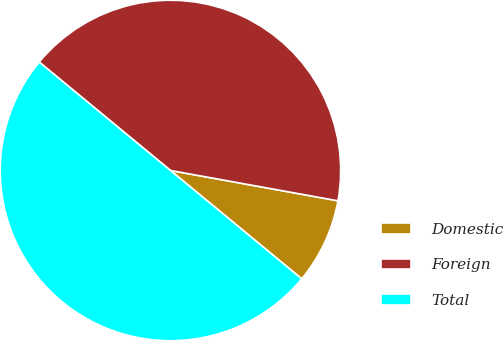<chart> <loc_0><loc_0><loc_500><loc_500><pie_chart><fcel>Domestic<fcel>Foreign<fcel>Total<nl><fcel>8.13%<fcel>41.87%<fcel>50.0%<nl></chart> 